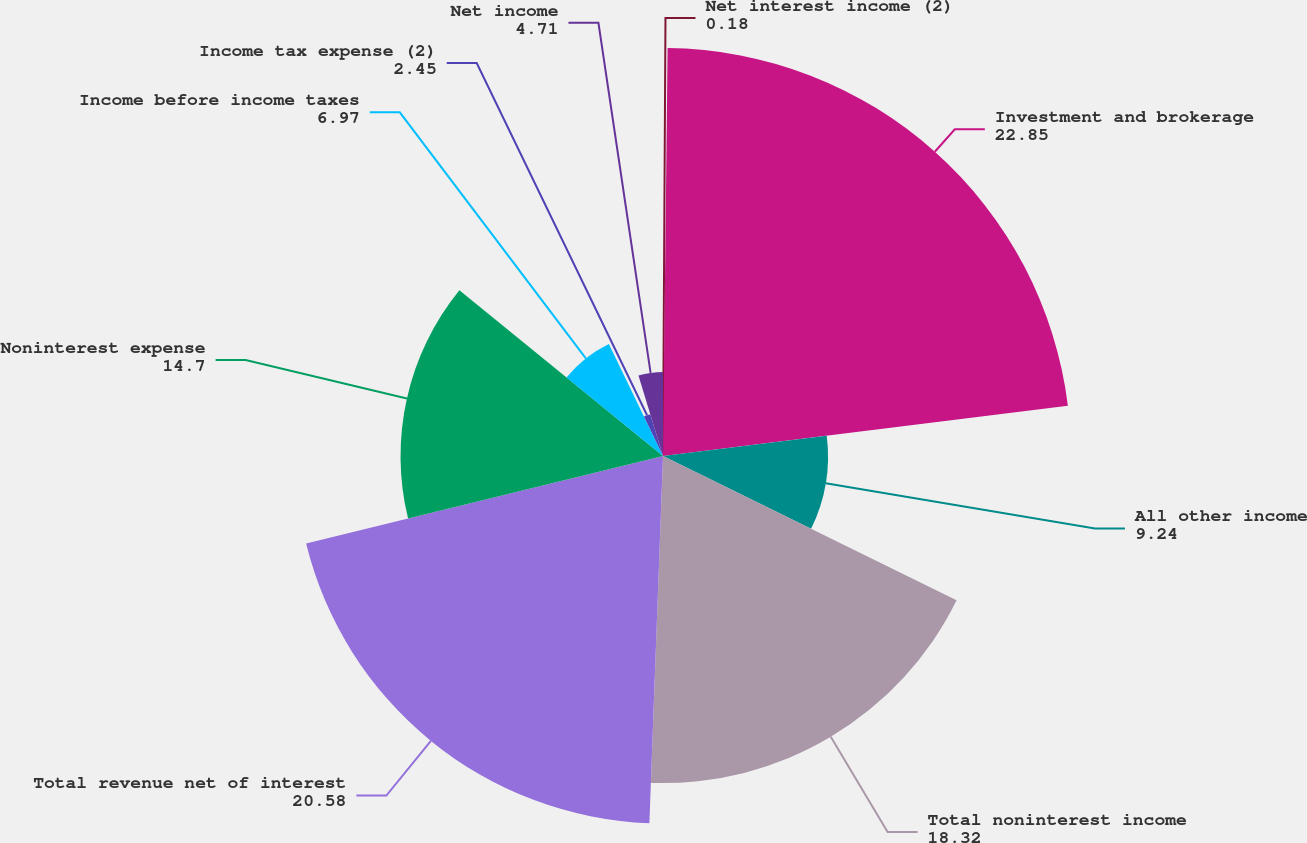<chart> <loc_0><loc_0><loc_500><loc_500><pie_chart><fcel>Net interest income (2)<fcel>Investment and brokerage<fcel>All other income<fcel>Total noninterest income<fcel>Total revenue net of interest<fcel>Noninterest expense<fcel>Income before income taxes<fcel>Income tax expense (2)<fcel>Net income<nl><fcel>0.18%<fcel>22.85%<fcel>9.24%<fcel>18.32%<fcel>20.58%<fcel>14.7%<fcel>6.97%<fcel>2.45%<fcel>4.71%<nl></chart> 